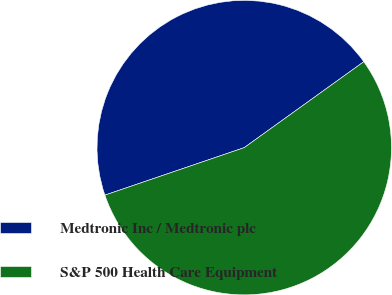Convert chart to OTSL. <chart><loc_0><loc_0><loc_500><loc_500><pie_chart><fcel>Medtronic Inc / Medtronic plc<fcel>S&P 500 Health Care Equipment<nl><fcel>45.31%<fcel>54.69%<nl></chart> 